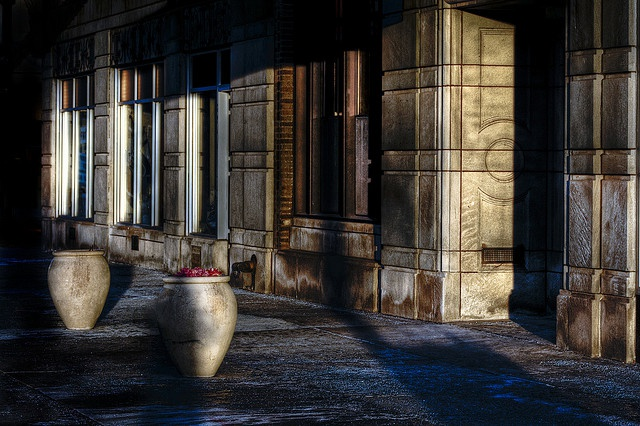Describe the objects in this image and their specific colors. I can see potted plant in black, darkgray, gray, and tan tones and vase in black, gray, and tan tones in this image. 